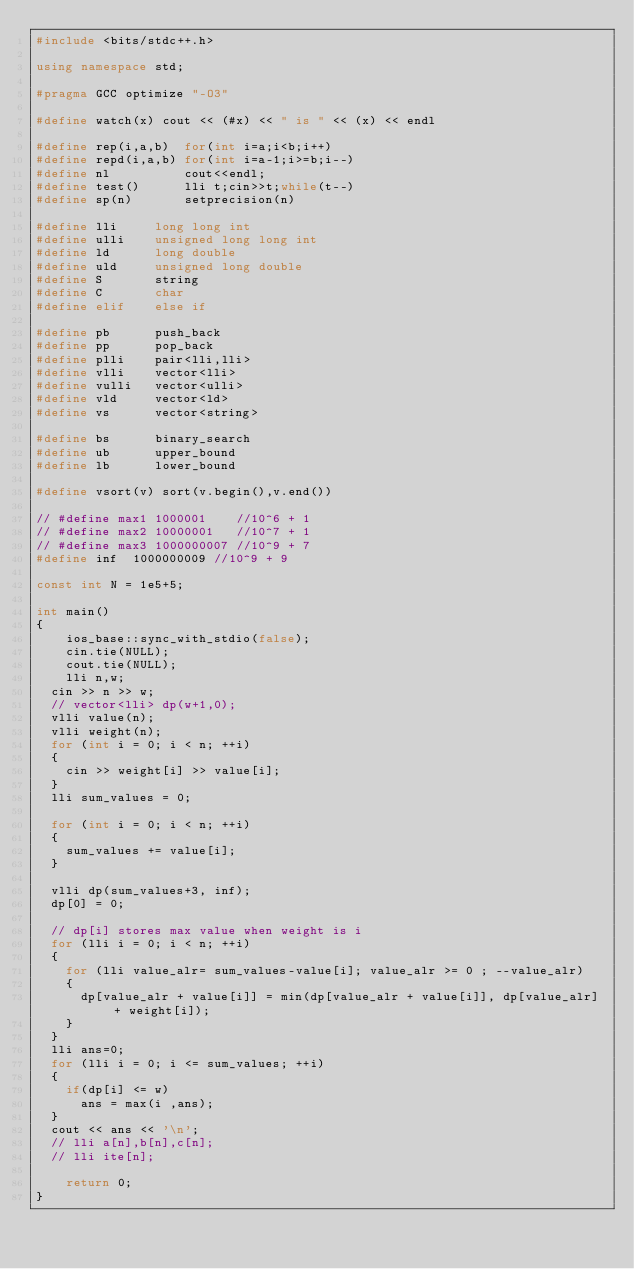Convert code to text. <code><loc_0><loc_0><loc_500><loc_500><_C++_>#include <bits/stdc++.h>

using namespace std;

#pragma GCC optimize "-O3"

#define watch(x) cout << (#x) << " is " << (x) << endl

#define rep(i,a,b)  for(int i=a;i<b;i++)
#define repd(i,a,b) for(int i=a-1;i>=b;i--)
#define nl          cout<<endl;
#define test()      lli t;cin>>t;while(t--)
#define sp(n)       setprecision(n)

#define lli     long long int
#define ulli    unsigned long long int
#define ld      long double
#define uld     unsigned long double
#define S       string
#define C       char
#define elif    else if
 
#define pb      push_back
#define pp      pop_back
#define plli    pair<lli,lli>
#define vlli    vector<lli>
#define vulli   vector<ulli>
#define vld     vector<ld>
#define vs      vector<string>

#define bs      binary_search
#define ub      upper_bound
#define lb      lower_bound

#define vsort(v) sort(v.begin(),v.end())

// #define max1 1000001    //10^6 + 1
// #define max2 10000001   //10^7 + 1
// #define max3 1000000007 //10^9 + 7
#define inf  1000000009 //10^9 + 9

const int N = 1e5+5;

int main()
{
    ios_base::sync_with_stdio(false);
    cin.tie(NULL);
    cout.tie(NULL);
    lli n,w;
 	cin >> n >> w;
 	// vector<lli> dp(w+1,0);
 	vlli value(n);
 	vlli weight(n);
 	for (int i = 0; i < n; ++i)
 	{
 		cin >> weight[i] >> value[i];
 	}	
 	lli sum_values = 0;

 	for (int i = 0; i < n; ++i)
 	{
 		sum_values += value[i];
 	}

 	vlli dp(sum_values+3, inf);
 	dp[0] = 0;

 	// dp[i] stores max value when weight is i
 	for (lli i = 0; i < n; ++i)
 	{
 		for (lli value_alr= sum_values-value[i]; value_alr >= 0 ; --value_alr)
 		{
 			dp[value_alr + value[i]] = min(dp[value_alr + value[i]], dp[value_alr] + weight[i]);
 		}
 	}
 	lli ans=0;
 	for (lli i = 0; i <= sum_values; ++i)
 	{
 		if(dp[i] <= w)
 			ans = max(i ,ans);
 	}
 	cout << ans << '\n';
 	// lli a[n],b[n],c[n];
 	// lli ite[n];
    
    return 0;
}
</code> 